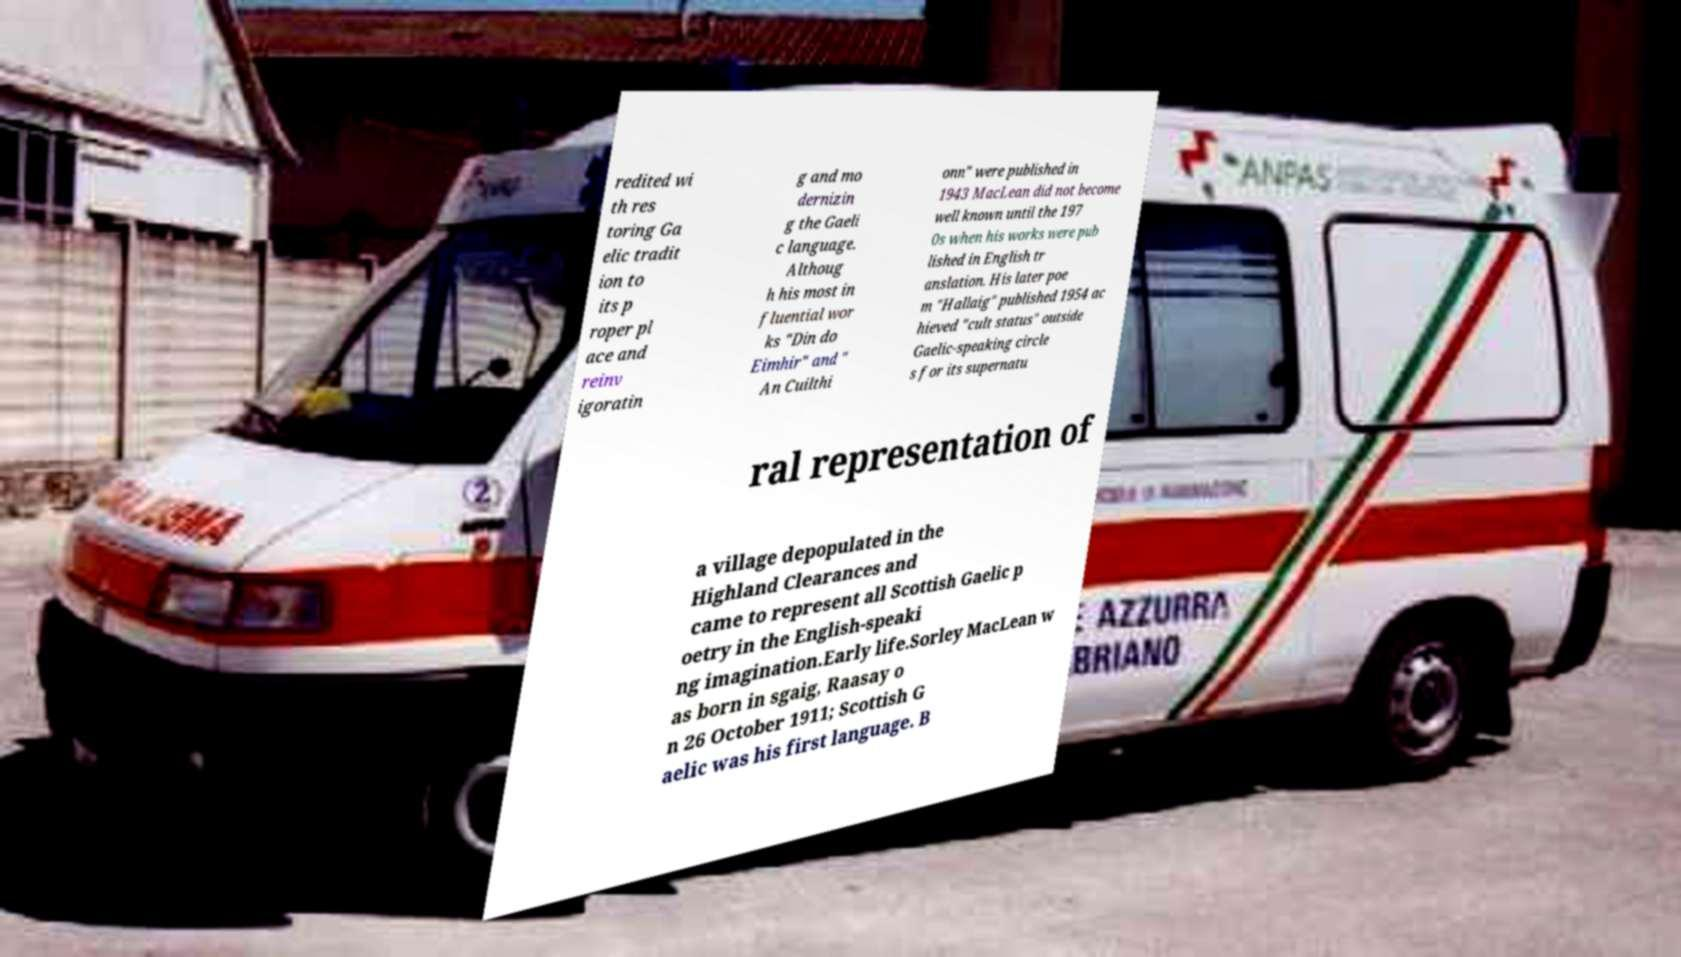Please read and relay the text visible in this image. What does it say? redited wi th res toring Ga elic tradit ion to its p roper pl ace and reinv igoratin g and mo dernizin g the Gaeli c language. Althoug h his most in fluential wor ks "Din do Eimhir" and " An Cuilthi onn" were published in 1943 MacLean did not become well known until the 197 0s when his works were pub lished in English tr anslation. His later poe m "Hallaig" published 1954 ac hieved "cult status" outside Gaelic-speaking circle s for its supernatu ral representation of a village depopulated in the Highland Clearances and came to represent all Scottish Gaelic p oetry in the English-speaki ng imagination.Early life.Sorley MacLean w as born in sgaig, Raasay o n 26 October 1911; Scottish G aelic was his first language. B 